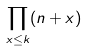<formula> <loc_0><loc_0><loc_500><loc_500>\prod _ { x \leq k } ( n + x )</formula> 